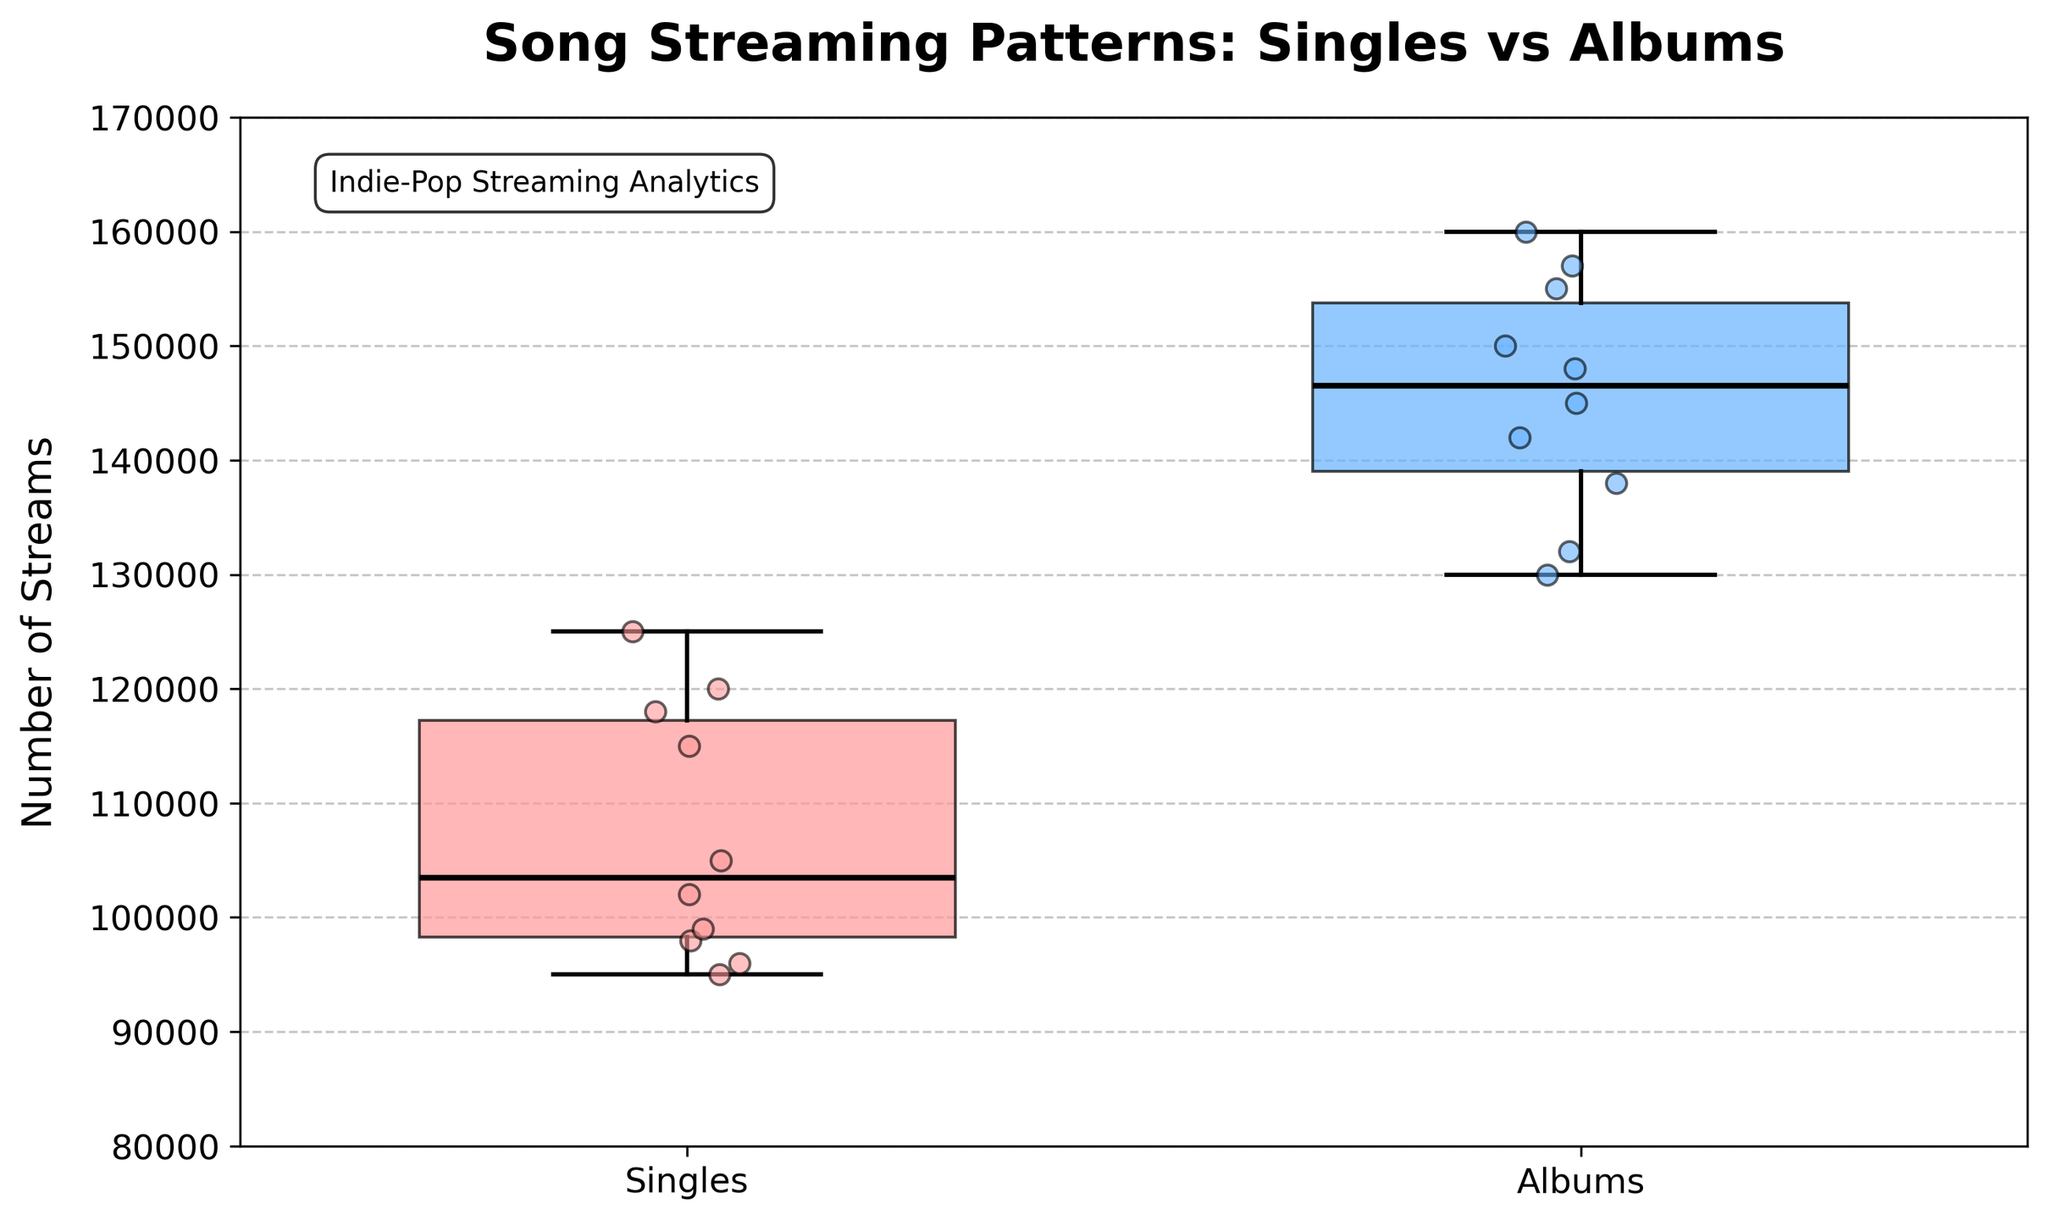What is the title of the plot? The title of the plot is found at the top center of the figure. It states, "Song Streaming Patterns: Singles vs Albums".
Answer: Song Streaming Patterns: Singles vs Albums Which release type category has the higher median number of streams? To determine the higher median number of streams, look at the horizontal lines within each box. The horizontal line (median) within the box for Albums is higher than that for Singles.
Answer: Albums What's the range of the y-axis? The y-axis range can be identified from the minimum and maximum values listed along the y-axis. Here, it ranges from 80,000 to 170,000 streams.
Answer: 80,000 to 170,000 How many singles were plotted in the figure? Look at the jittered points scattered around the "Singles" category. By counting each point, you find there are 10 singles.
Answer: 10 How do the upper quartiles of singles and albums compare? The upper quartile for each release type is the top of the colored box. For Singles, it is approximately 118,000; for Albums, it is roughly 155,000. Albums have a higher upper quartile.
Answer: Albums have a higher upper quartile What is the visual difference between the colors of the boxes for Singles and Albums? The colored boxes in the figure are painted differently for each category. Singles are light red, while Albums are light blue.
Answer: Singles are light red, Albums are light blue Which group has the highest extreme value (the highest individual point)? The highest individual point can be seen at the top of the scattered points. For Albums, the top point reaches 160,000 streams, while Singles' highest point is significantly lower.
Answer: Albums What is the median stream count for Singles approximately? The median stream count for Singles is indicated by the black horizontal line within the Singles box. It is roughly 102,000.
Answer: 102,000 Which release type shows more variability in the number of streams? Variability can be judged by the length of the whiskers and the spread of the points. Albums have a larger spread between their whiskers compared to Singles, showing greater variability.
Answer: Albums Is the median stream count for Albums greater than 140,000? Observing the median line within the Albums box and where it stands compared to the y-axis values, it is noted the median exceeds 140,000.
Answer: Yes 